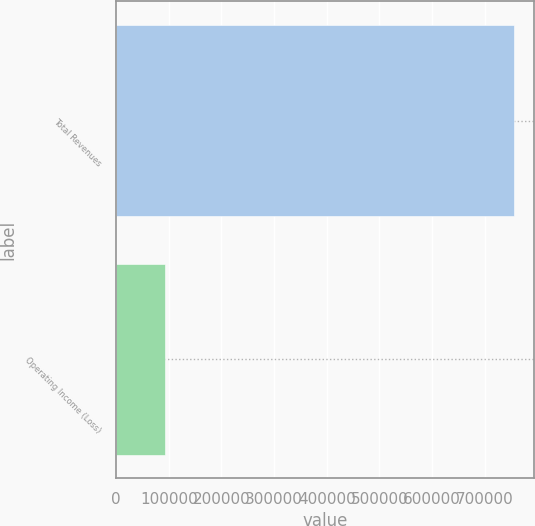Convert chart. <chart><loc_0><loc_0><loc_500><loc_500><bar_chart><fcel>Total Revenues<fcel>Operating Income (Loss)<nl><fcel>755542<fcel>93623<nl></chart> 